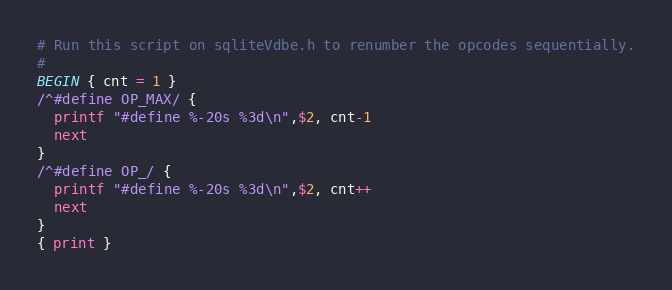Convert code to text. <code><loc_0><loc_0><loc_500><loc_500><_Awk_># Run this script on sqliteVdbe.h to renumber the opcodes sequentially.
#
BEGIN { cnt = 1 }
/^#define OP_MAX/ {
  printf "#define %-20s %3d\n",$2, cnt-1
  next
}
/^#define OP_/ {
  printf "#define %-20s %3d\n",$2, cnt++
  next
}
{ print }
</code> 